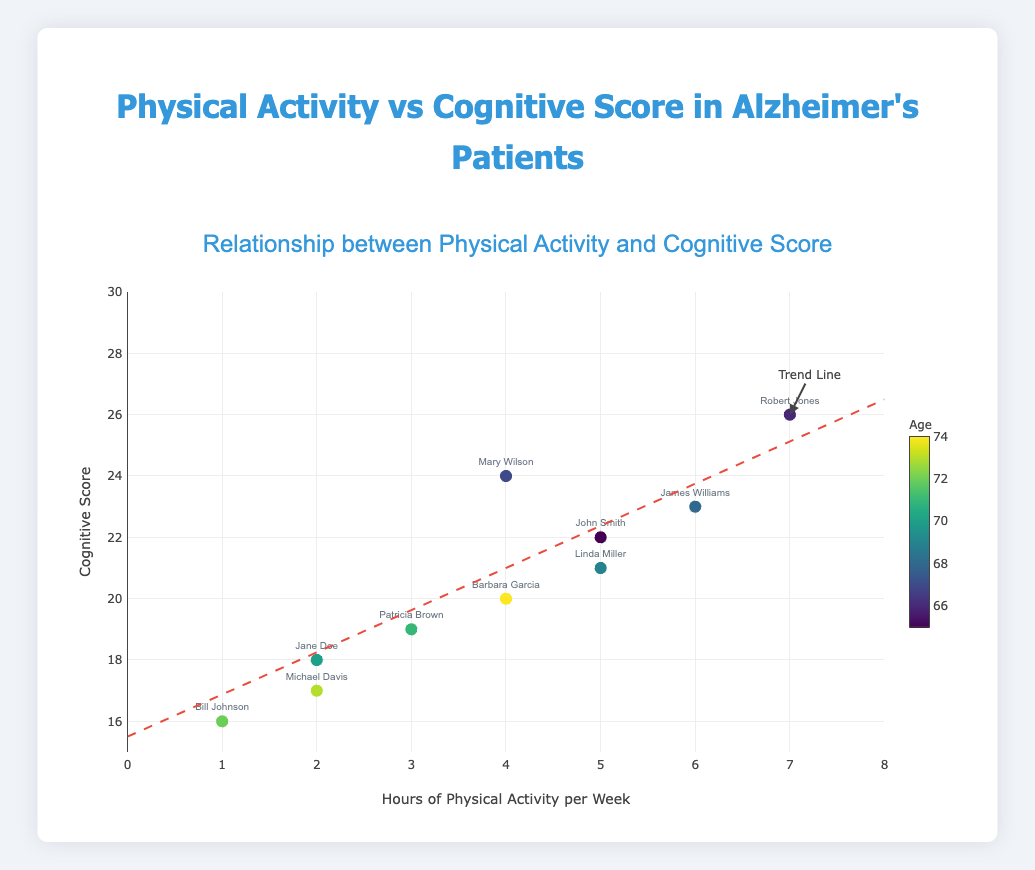What is the title of the figure? The title of the figure is located at the top and is highlighted to convey the main message or purpose of the visual. In this case, it is labeled in a larger, distinct font.
Answer: Physical Activity vs Cognitive Score in Alzheimer's Patients How many data points are plotted in the figure? By counting the number of unique markers (scatter points) displayed in the figure, each representing a participant, we can determine the total number of data points. In this case, 10 individual data points are plotted.
Answer: 10 What does the x-axis represent? The x-axis of the figure is labeled, denoting the variable represented along this axis. It signifies "Hours of Physical Activity per Week" as indicated by the detailed axis description and ticks ranging from 0 to 8.
Answer: Hours of Physical Activity per Week What is the range of cognitive scores plotted on the y-axis? Observing the y-axis, we can see the range from the lowest to the highest tick marks provided. The cognitive scores range from 15 to 30, as indicated by these markings.
Answer: 15 to 30 Which participant has the highest cognitive score and how many hours of physical activity do they engage in per week? Identify the data point with the maximum y-value, representing the highest cognitive score. The hover text helps to confirm that Robert Jones has the highest score of 26 and engages in 7 hours of physical activity per week.
Answer: Robert Jones, 7 hours Is there a visible trend between physical activity and cognitive score? The trend line shown in the figure (dashed line) helps to determine the correlation. From the plotted trend line, it is apparent that there is a positive trend; as the hours of physical activity per week increase, the cognitive scores tend to rise.
Answer: Yes, a positive trend What is the cognitive score of the participant who engages in 5 hours of physical activity per week and has reached the maximum age? From the markers and hover texts on the plot, for participants who engage in 5 hours of activity, we identify the oldest. Linda Miller, aged 69, participates for 5 hours and has a cognitive score of 21.
Answer: 21 Compare the cognitive scores of participants who engage in 2 hours and 6 hours of physical activity. Who has higher scores on average? To find the average cognitive scores, sum the scores and divide by the number of participants for each activity duration. For 2 hours: (18 + 17) / 2 = 17.5. For 6 hours: only one participant with a score of 23. Compare the averages.
Answer: 6 hours, 23 Which participant has the lowest amount of physical activity, and what is their cognitive score? Locate the data point with the minimum x-value, which signifies the least physical activity. Bill Johnson has 1 hour of activity per week, with a cognitive score of 16, as confirmed by the hover text.
Answer: Bill Johnson, 16 What is the color of the trend line in the figure? Examine the visual attributes of the trend line, indicated by its distinct appearance and style. It is colored red to distinguish it from other elements in the plot.
Answer: Red 